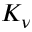Convert formula to latex. <formula><loc_0><loc_0><loc_500><loc_500>K _ { \nu }</formula> 